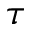Convert formula to latex. <formula><loc_0><loc_0><loc_500><loc_500>\tau</formula> 